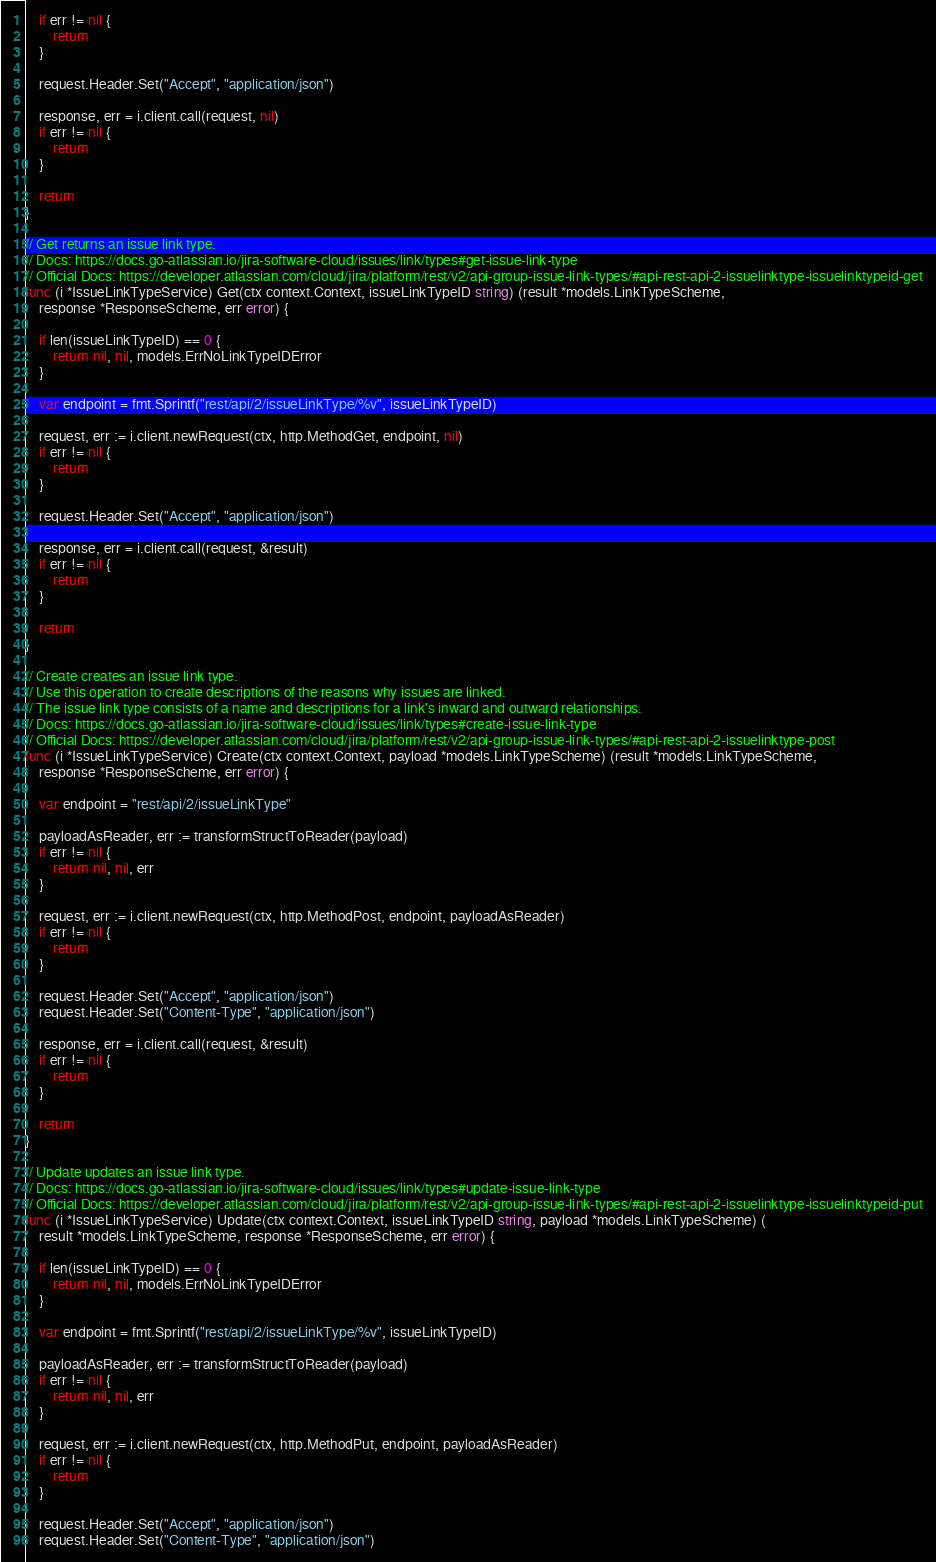Convert code to text. <code><loc_0><loc_0><loc_500><loc_500><_Go_>	if err != nil {
		return
	}

	request.Header.Set("Accept", "application/json")

	response, err = i.client.call(request, nil)
	if err != nil {
		return
	}

	return
}

// Get returns an issue link type.
// Docs: https://docs.go-atlassian.io/jira-software-cloud/issues/link/types#get-issue-link-type
// Official Docs: https://developer.atlassian.com/cloud/jira/platform/rest/v2/api-group-issue-link-types/#api-rest-api-2-issuelinktype-issuelinktypeid-get
func (i *IssueLinkTypeService) Get(ctx context.Context, issueLinkTypeID string) (result *models.LinkTypeScheme,
	response *ResponseScheme, err error) {

	if len(issueLinkTypeID) == 0 {
		return nil, nil, models.ErrNoLinkTypeIDError
	}

	var endpoint = fmt.Sprintf("rest/api/2/issueLinkType/%v", issueLinkTypeID)

	request, err := i.client.newRequest(ctx, http.MethodGet, endpoint, nil)
	if err != nil {
		return
	}

	request.Header.Set("Accept", "application/json")

	response, err = i.client.call(request, &result)
	if err != nil {
		return
	}

	return
}

// Create creates an issue link type.
// Use this operation to create descriptions of the reasons why issues are linked.
// The issue link type consists of a name and descriptions for a link's inward and outward relationships.
// Docs: https://docs.go-atlassian.io/jira-software-cloud/issues/link/types#create-issue-link-type
// Official Docs: https://developer.atlassian.com/cloud/jira/platform/rest/v2/api-group-issue-link-types/#api-rest-api-2-issuelinktype-post
func (i *IssueLinkTypeService) Create(ctx context.Context, payload *models.LinkTypeScheme) (result *models.LinkTypeScheme,
	response *ResponseScheme, err error) {

	var endpoint = "rest/api/2/issueLinkType"

	payloadAsReader, err := transformStructToReader(payload)
	if err != nil {
		return nil, nil, err
	}

	request, err := i.client.newRequest(ctx, http.MethodPost, endpoint, payloadAsReader)
	if err != nil {
		return
	}

	request.Header.Set("Accept", "application/json")
	request.Header.Set("Content-Type", "application/json")

	response, err = i.client.call(request, &result)
	if err != nil {
		return
	}

	return
}

// Update updates an issue link type.
// Docs: https://docs.go-atlassian.io/jira-software-cloud/issues/link/types#update-issue-link-type
// Official Docs: https://developer.atlassian.com/cloud/jira/platform/rest/v2/api-group-issue-link-types/#api-rest-api-2-issuelinktype-issuelinktypeid-put
func (i *IssueLinkTypeService) Update(ctx context.Context, issueLinkTypeID string, payload *models.LinkTypeScheme) (
	result *models.LinkTypeScheme, response *ResponseScheme, err error) {

	if len(issueLinkTypeID) == 0 {
		return nil, nil, models.ErrNoLinkTypeIDError
	}

	var endpoint = fmt.Sprintf("rest/api/2/issueLinkType/%v", issueLinkTypeID)

	payloadAsReader, err := transformStructToReader(payload)
	if err != nil {
		return nil, nil, err
	}

	request, err := i.client.newRequest(ctx, http.MethodPut, endpoint, payloadAsReader)
	if err != nil {
		return
	}

	request.Header.Set("Accept", "application/json")
	request.Header.Set("Content-Type", "application/json")
</code> 